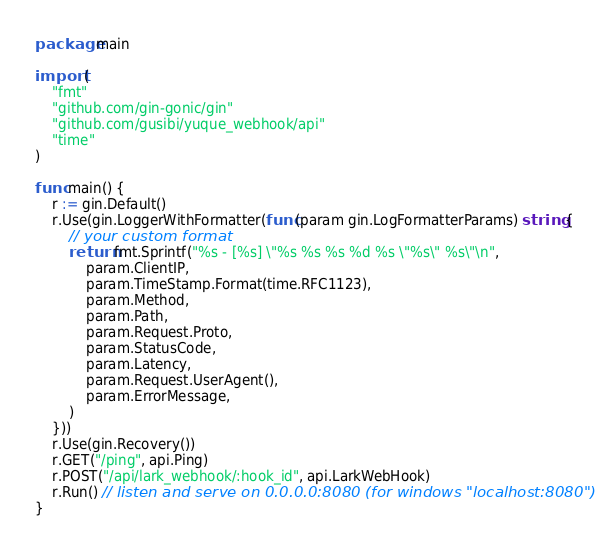<code> <loc_0><loc_0><loc_500><loc_500><_Go_>package main

import (
	"fmt"
	"github.com/gin-gonic/gin"
	"github.com/gusibi/yuque_webhook/api"
	"time"
)

func main() {
	r := gin.Default()
	r.Use(gin.LoggerWithFormatter(func(param gin.LogFormatterParams) string {
		// your custom format
		return fmt.Sprintf("%s - [%s] \"%s %s %s %d %s \"%s\" %s\"\n",
			param.ClientIP,
			param.TimeStamp.Format(time.RFC1123),
			param.Method,
			param.Path,
			param.Request.Proto,
			param.StatusCode,
			param.Latency,
			param.Request.UserAgent(),
			param.ErrorMessage,
		)
	}))
	r.Use(gin.Recovery())
	r.GET("/ping", api.Ping)
	r.POST("/api/lark_webhook/:hook_id", api.LarkWebHook)
	r.Run() // listen and serve on 0.0.0.0:8080 (for windows "localhost:8080")
}
</code> 